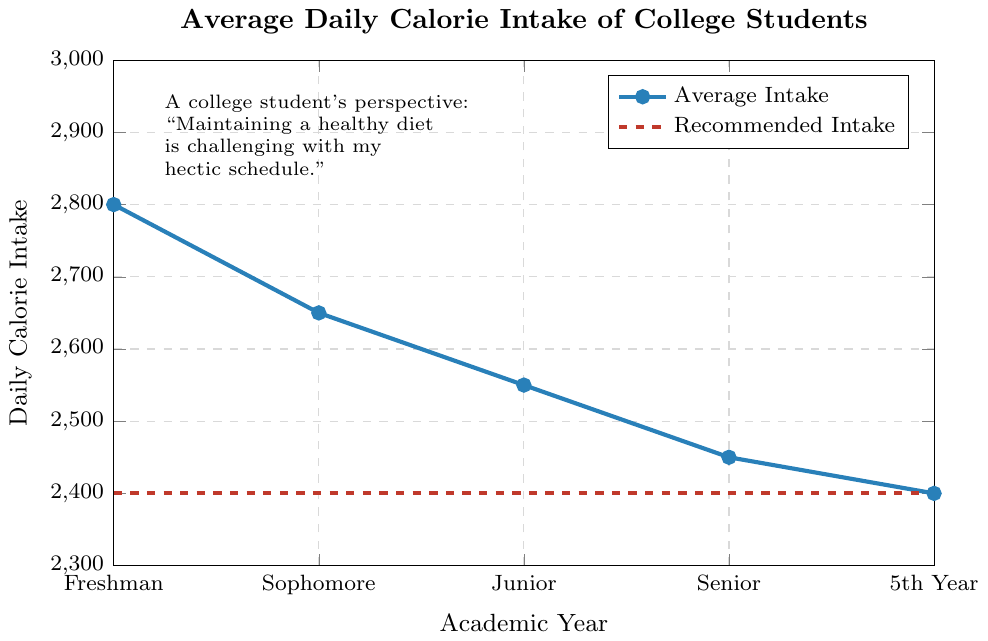What's the trend in average daily calorie intake from freshman to senior year? From the figure, the average daily calorie intake decreases each academic year. Starting from freshman (2800), sophomore (2650), junior (2550), and senior (2450). The trend shows a consistent decrease.
Answer: Decreasing How does the average daily calorie intake for freshmen compare to the recommended intake? The average intake for freshmen is higher than the recommended intake. The figure shows that freshmen have 2800 calories, while the recommended is 2400. The difference is 2800 - 2400.
Answer: Higher by 400 In which academic year does the average daily calorie intake equal the recommended level? From the figure, the average intake equals the recommended level of 2400 calories in the 5th year.
Answer: 5th Year By how much does the average daily calorie intake decrease from freshman to senior year? To find the decrease, subtract the senior year intake (2450) from the freshman year intake (2800). The decrease is 2800 - 2450.
Answer: 350 calories Between which two consecutive academic years is the largest drop in average daily calorie intake observed? Based on the figure, the largest drop is between freshman (2800) and sophomore (2650). The drop is 2800 - 2650, which equals 150.
Answer: Between Freshman and Sophomore What is the visual representation (color) for the average daily calorie intake line compared to the recommended intake line? The figure uses a blue line to represent the average daily calorie intake and a red dashed line for the recommended intake.
Answer: Blue for average intake, Red dashed for recommended How many academic years have an average daily calorie intake above the recommended level? By examining the plot, the average daily calorie intake is above the recommended level for Freshman, Sophomore, Junior, and Senior years.
Answer: Four years What's the average of all the average daily calorie intakes shown on the figure? Sum the average daily calorie intakes: 2800 + 2650 + 2550 + 2450 + 2400 = 12850. Divide by the number of years (5), the average is 12850 / 5.
Answer: 2570 calories Which academic year shows the smallest difference between the average daily intake and recommended intake? From the figure, the 5th Year shows the smallest difference as it matches the recommended intake exactly at 2400 calories.
Answer: 5th Year 